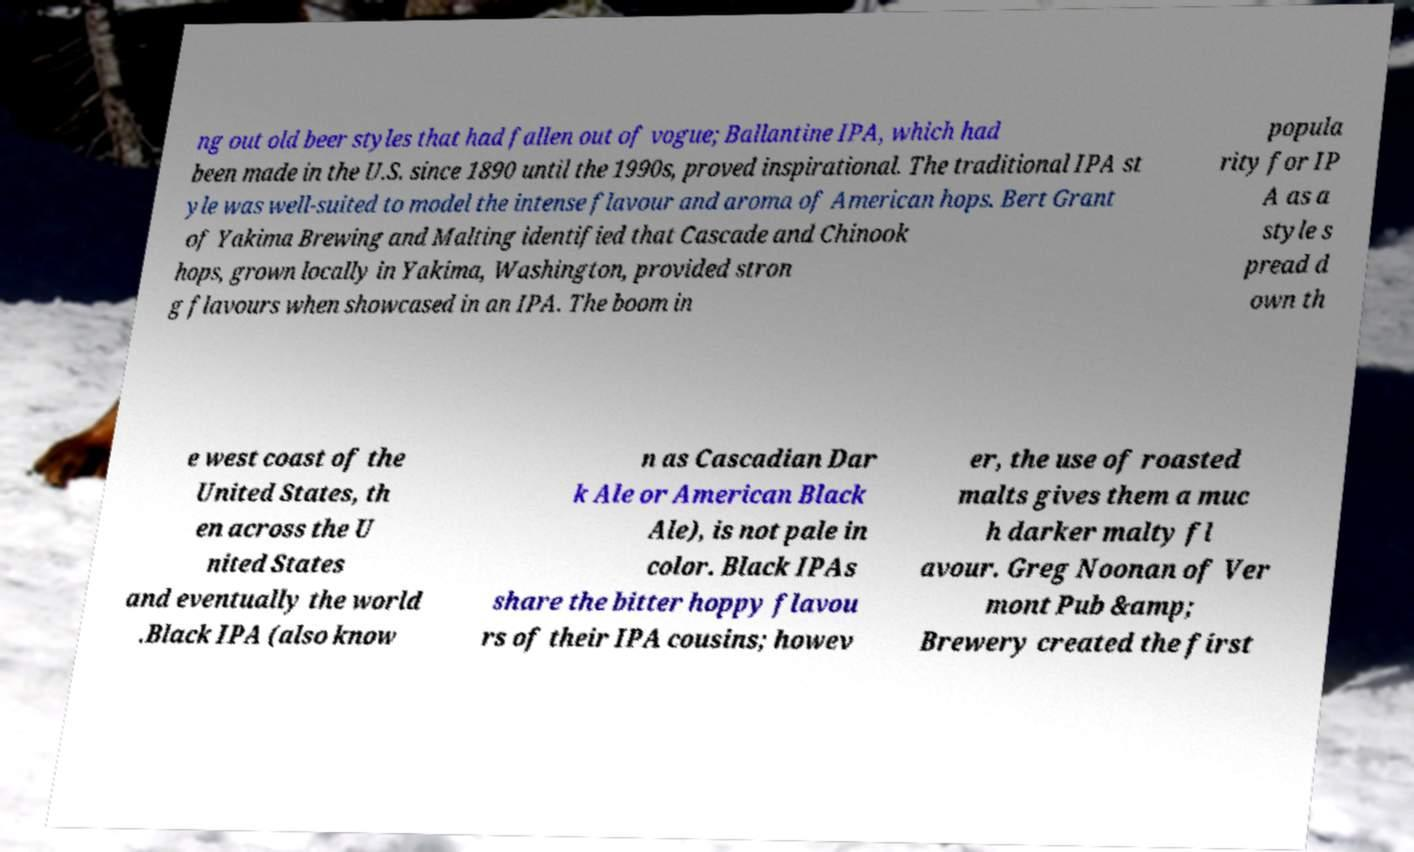Can you read and provide the text displayed in the image?This photo seems to have some interesting text. Can you extract and type it out for me? ng out old beer styles that had fallen out of vogue; Ballantine IPA, which had been made in the U.S. since 1890 until the 1990s, proved inspirational. The traditional IPA st yle was well-suited to model the intense flavour and aroma of American hops. Bert Grant of Yakima Brewing and Malting identified that Cascade and Chinook hops, grown locally in Yakima, Washington, provided stron g flavours when showcased in an IPA. The boom in popula rity for IP A as a style s pread d own th e west coast of the United States, th en across the U nited States and eventually the world .Black IPA (also know n as Cascadian Dar k Ale or American Black Ale), is not pale in color. Black IPAs share the bitter hoppy flavou rs of their IPA cousins; howev er, the use of roasted malts gives them a muc h darker malty fl avour. Greg Noonan of Ver mont Pub &amp; Brewery created the first 